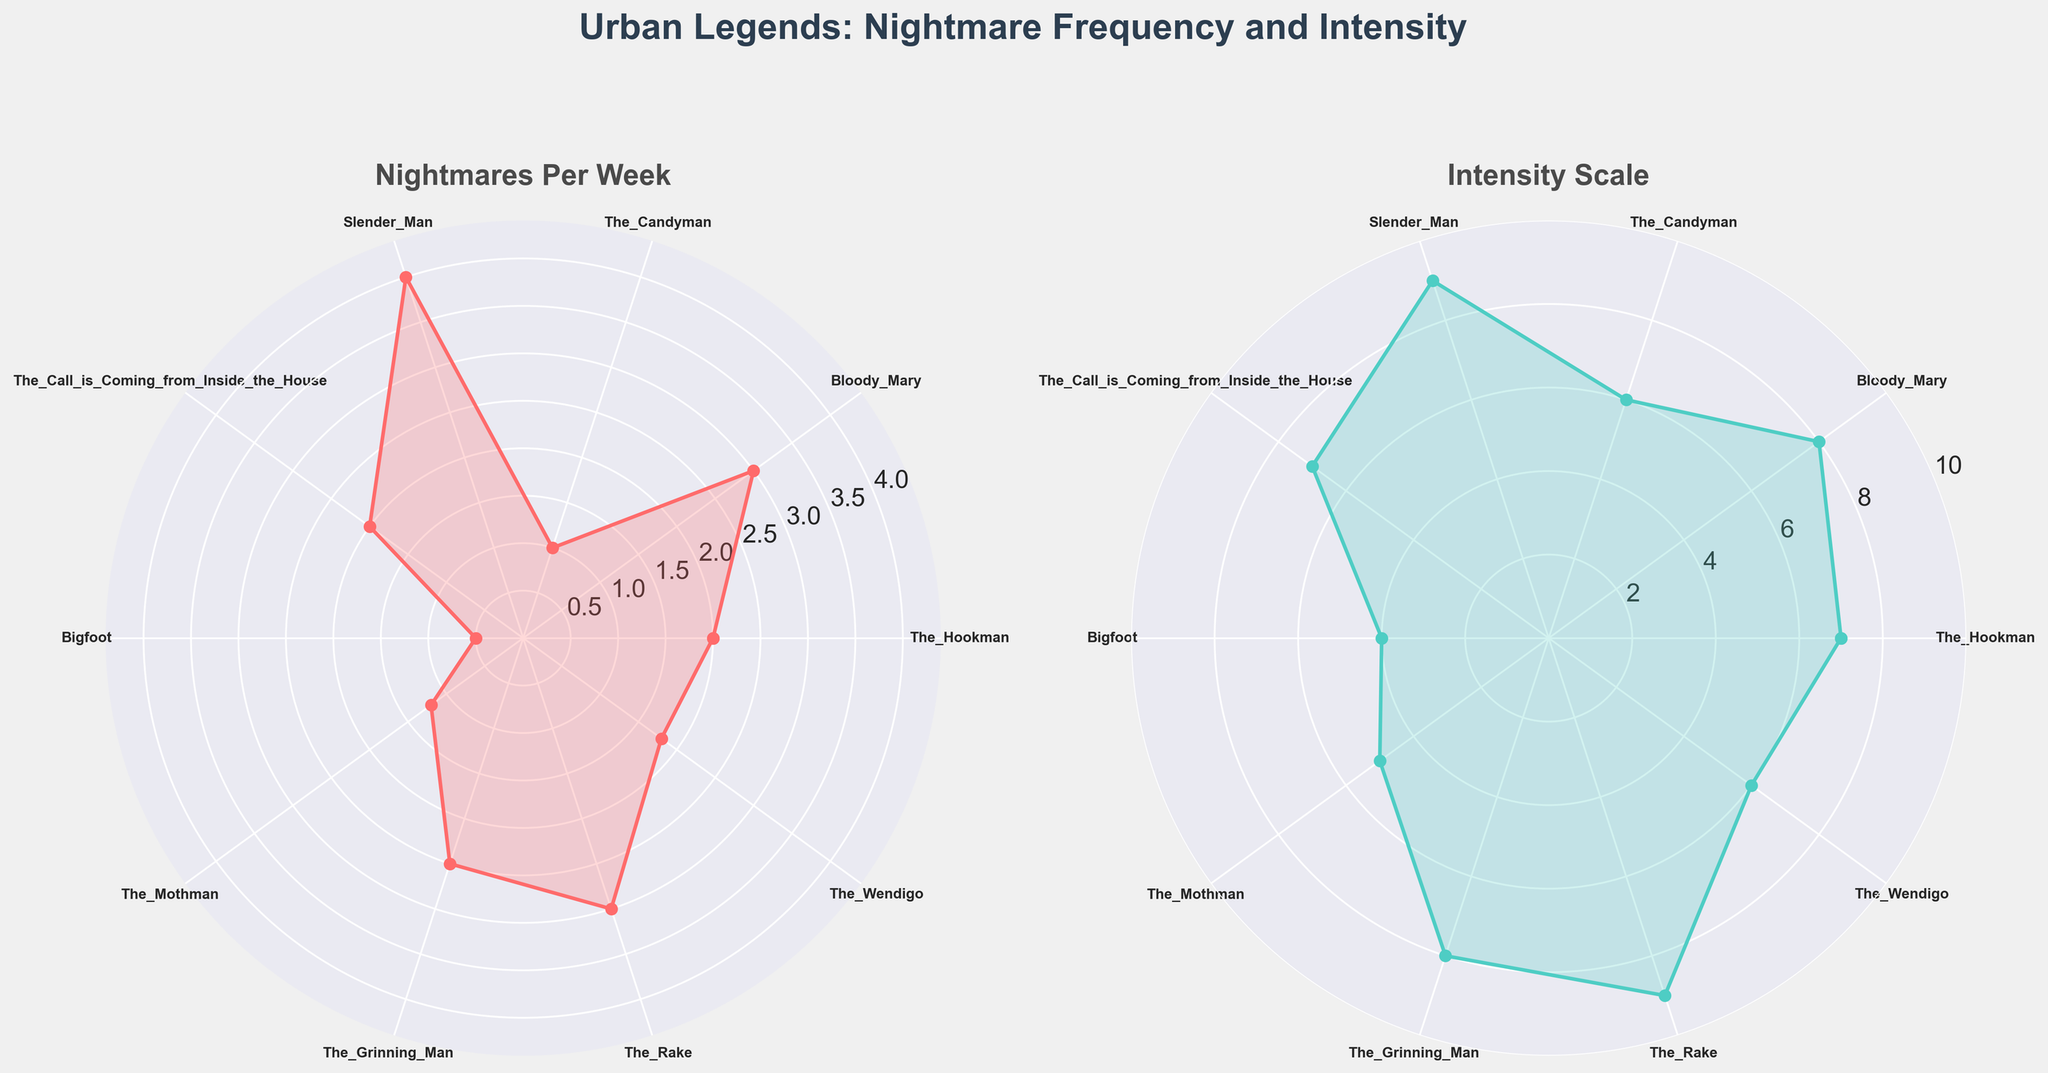What is the title of the figure? The title is prominently displayed at the top of the figure. It reads "Urban Legends: Nightmare Frequency and Intensity".
Answer: Urban Legends: Nightmare Frequency and Intensity How many urban legends are represented in the figure? Each legend has a corresponding label around the perimeter of the polar charts. By counting these labels, we find that there are ten urban legends.
Answer: Ten Which urban legend is associated with the highest frequency of nightmares per week? By examining the first polar chart titled "Nightmares Per Week," we see that the point corresponding to Slender Man is at the highest radial distance from the center.
Answer: Slender Man What is the scale used for the intensity of nightmares, and what is the maximum intensity value? The second polar chart titled "Intensity Scale" has radials marked from 0 to 10. The maximum intensity value is clearly indicated at the outer edge of the scale.
Answer: 0 to 10; 10 How does the intensity of nightmares related to The Hookman compare to that of Bloody Mary? We need to look at the radial distance from the center for both legends in the intensity plot. The Hookman is at 7, while Bloody Mary is at 8.
Answer: The intensity for Bloody Mary is higher What is the mean intensity scale rating for all the urban legends? The intensity values are [7, 8, 6, 9, 7, 4, 5, 8, 9, 6]. To find the mean, we sum these values and divide by the number of legends: (7+8+6+9+7+4+5+8+9+6)/10 = 69/10 = 6.9.
Answer: 6.9 Which urban legend has the lowest number of nightmares per week, and what is that number? In the first polar chart, the point closest to the center represents Bigfoot, with a value of 0.5 nightmares per week.
Answer: Bigfoot, 0.5 Is there an urban legend that has the same intensity scale rating as its frequency of nightmares per week? We compare the values from both plots. No urban legend has the same values in both the "Nightmares Per Week" and "Intensity Scale" plots.
Answer: No What is the difference in the number of nightmares per week between Slender Man and The Candyman? Slender Man has 4 nightmares per week, and The Candyman has 1. The difference is 4 - 1 = 3.
Answer: 3 Which urban legend has an intensity scale rating equal to the median value, and what is that value? First, we find the median of the intensity scale values: sorted values are [4, 5, 6, 6, 7, 7, 8, 8, 9, 9]. The median is (7+7)/2 = 7. The legends with an intensity scale of 7 are The Hookman and The Call is Coming from Inside the House.
Answer: The Hookman, The Call is Coming from Inside the House; 7 